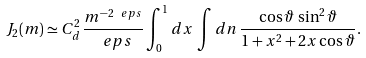<formula> <loc_0><loc_0><loc_500><loc_500>J _ { 2 } ( m ) \simeq C ^ { 2 } _ { d } \, \frac { m ^ { - 2 \ e p s } } { \ e p s } \int _ { 0 } ^ { 1 } d x \, \int d { n } \, \frac { \cos \vartheta \, \sin ^ { 2 } \vartheta } { 1 + x ^ { 2 } + 2 x \cos \vartheta } .</formula> 